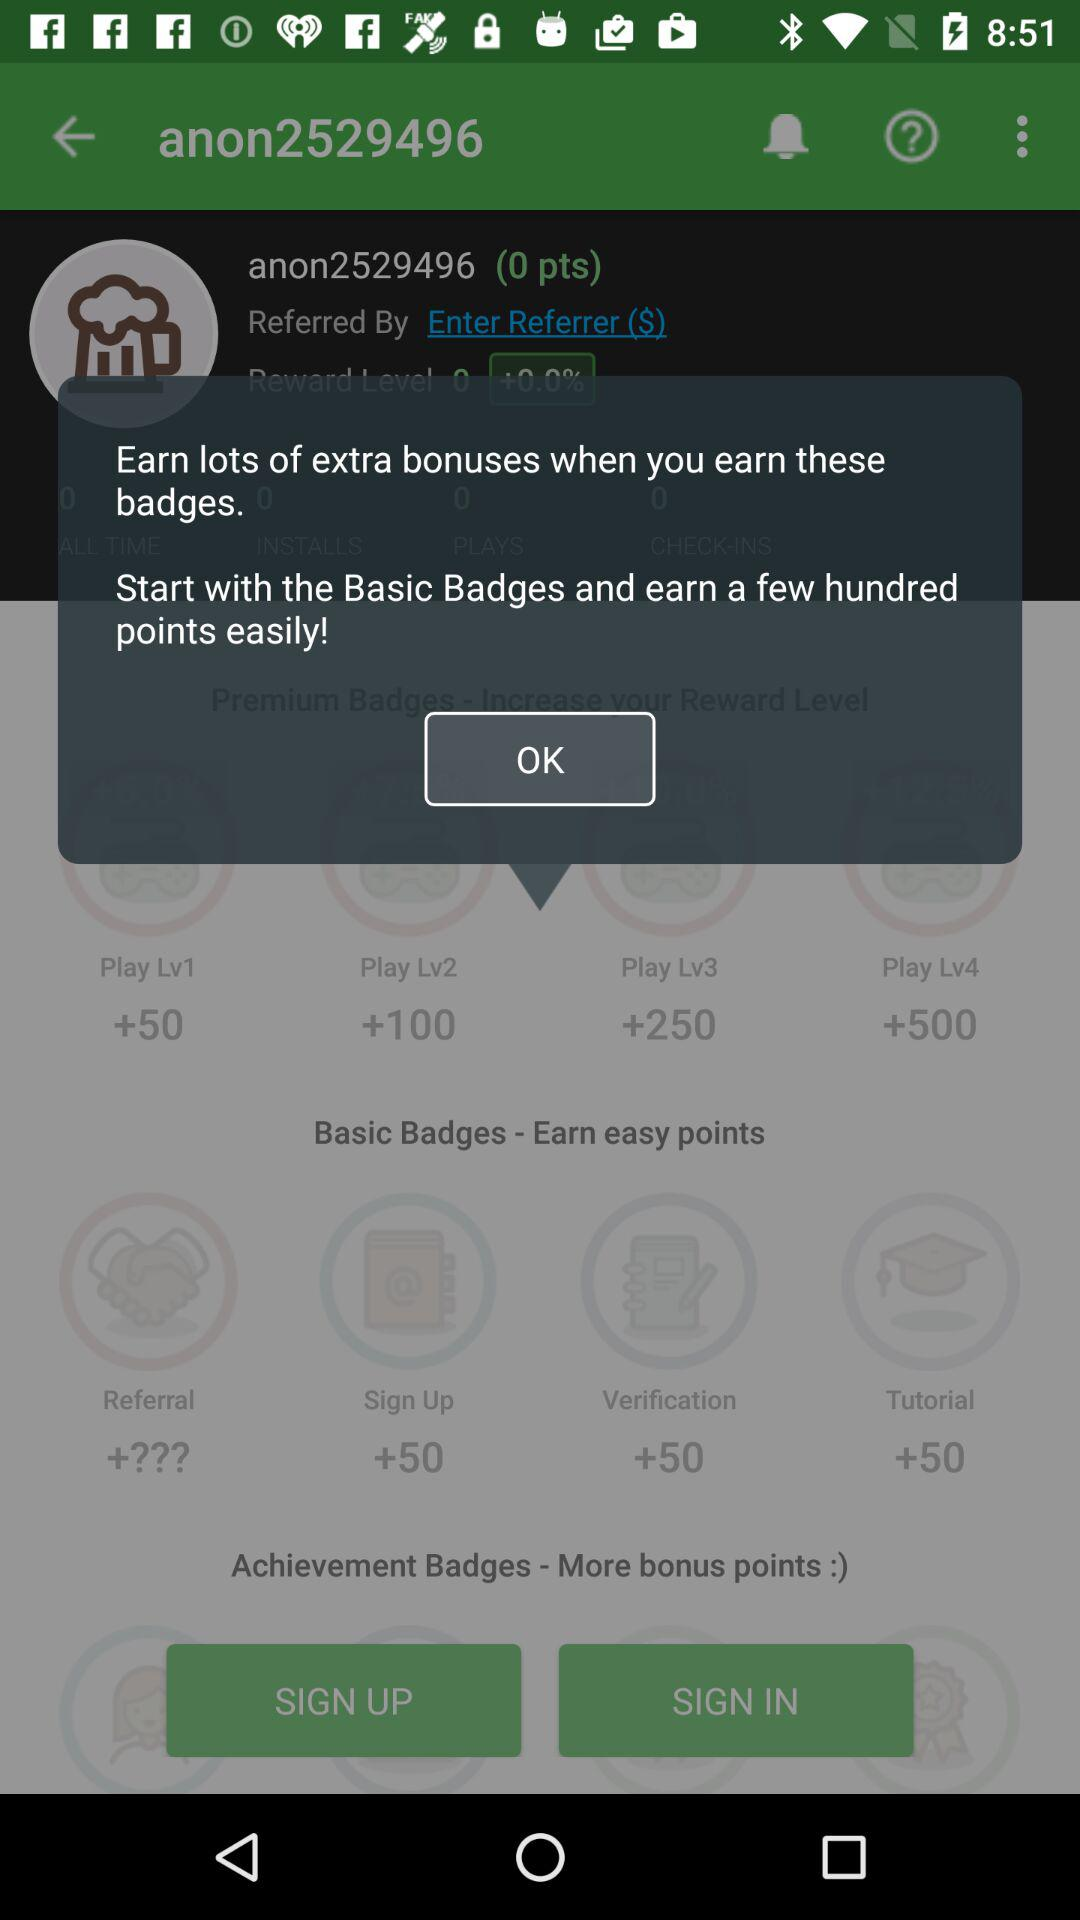How many points does "anon2529496" have? "anon2529496" has 0 points. 